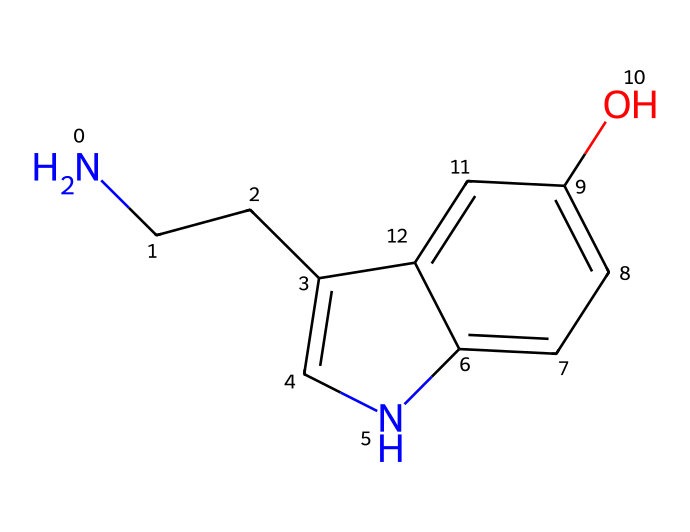What is the molecular formula of serotonin? To determine the molecular formula from the SMILES representation, we can identify the different atoms present in the structure. The structure has 10 carbon atoms, 12 hydrogen atoms, 1 nitrogen atom, and 1 oxygen atom. Thus, the molecular formula combines these counts, giving us C10H12N2O.
Answer: C10H12N2O How many rings are present in the structure? Upon analyzing the SMILES, we can see the presence of two connected rings formed in the structure. The "c" indicates aromatic carbon atoms, and there are two cyclic structures connected to the side chain.
Answer: 2 What type of amine is serotonin classified as? In the structure, there is a nitrogen atom with a single bond to a carbon chain, indicating it is part of a primary amine. The nitrogen does not have additional carbon substituents apart from those involved in the side chain.
Answer: primary amine How many hydroxyl (OH) groups are present? By examining the structure for the presence of hydroxyl functional groups (indicated by "O" connected to "H"), we find there is one hydroxyl group present attached to the aromatic ring.
Answer: 1 What is the role of serotonin in the body? Serotonin primarily acts as a neurotransmitter that contributes to feelings of well-being and happiness, linking it to mood regulation, sleep, and overall emotional balance.
Answer: mood regulation 